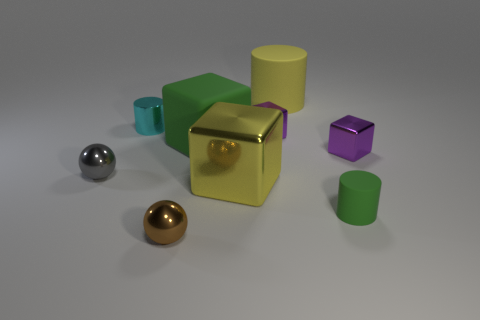Is there anything else that has the same color as the large shiny block?
Offer a terse response. Yes. What color is the matte object that is in front of the metal cylinder and behind the large yellow metallic object?
Offer a very short reply. Green. Does the purple cube that is on the left side of the green rubber cylinder have the same size as the green rubber cylinder?
Ensure brevity in your answer.  Yes. Are there more small green objects left of the large yellow metal block than cylinders?
Offer a terse response. No. Is the shape of the big metallic thing the same as the small cyan shiny object?
Provide a short and direct response. No. How big is the cyan metal thing?
Provide a short and direct response. Small. Are there more tiny purple metal blocks that are to the left of the large yellow cylinder than small gray metal things that are behind the matte block?
Your answer should be very brief. Yes. Are there any yellow metal blocks to the left of the tiny cyan cylinder?
Provide a short and direct response. No. Is there a cyan metal cube of the same size as the brown sphere?
Your answer should be very brief. No. There is another large cylinder that is made of the same material as the green cylinder; what is its color?
Provide a short and direct response. Yellow. 